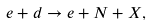Convert formula to latex. <formula><loc_0><loc_0><loc_500><loc_500>e + d \to e + N + X ,</formula> 